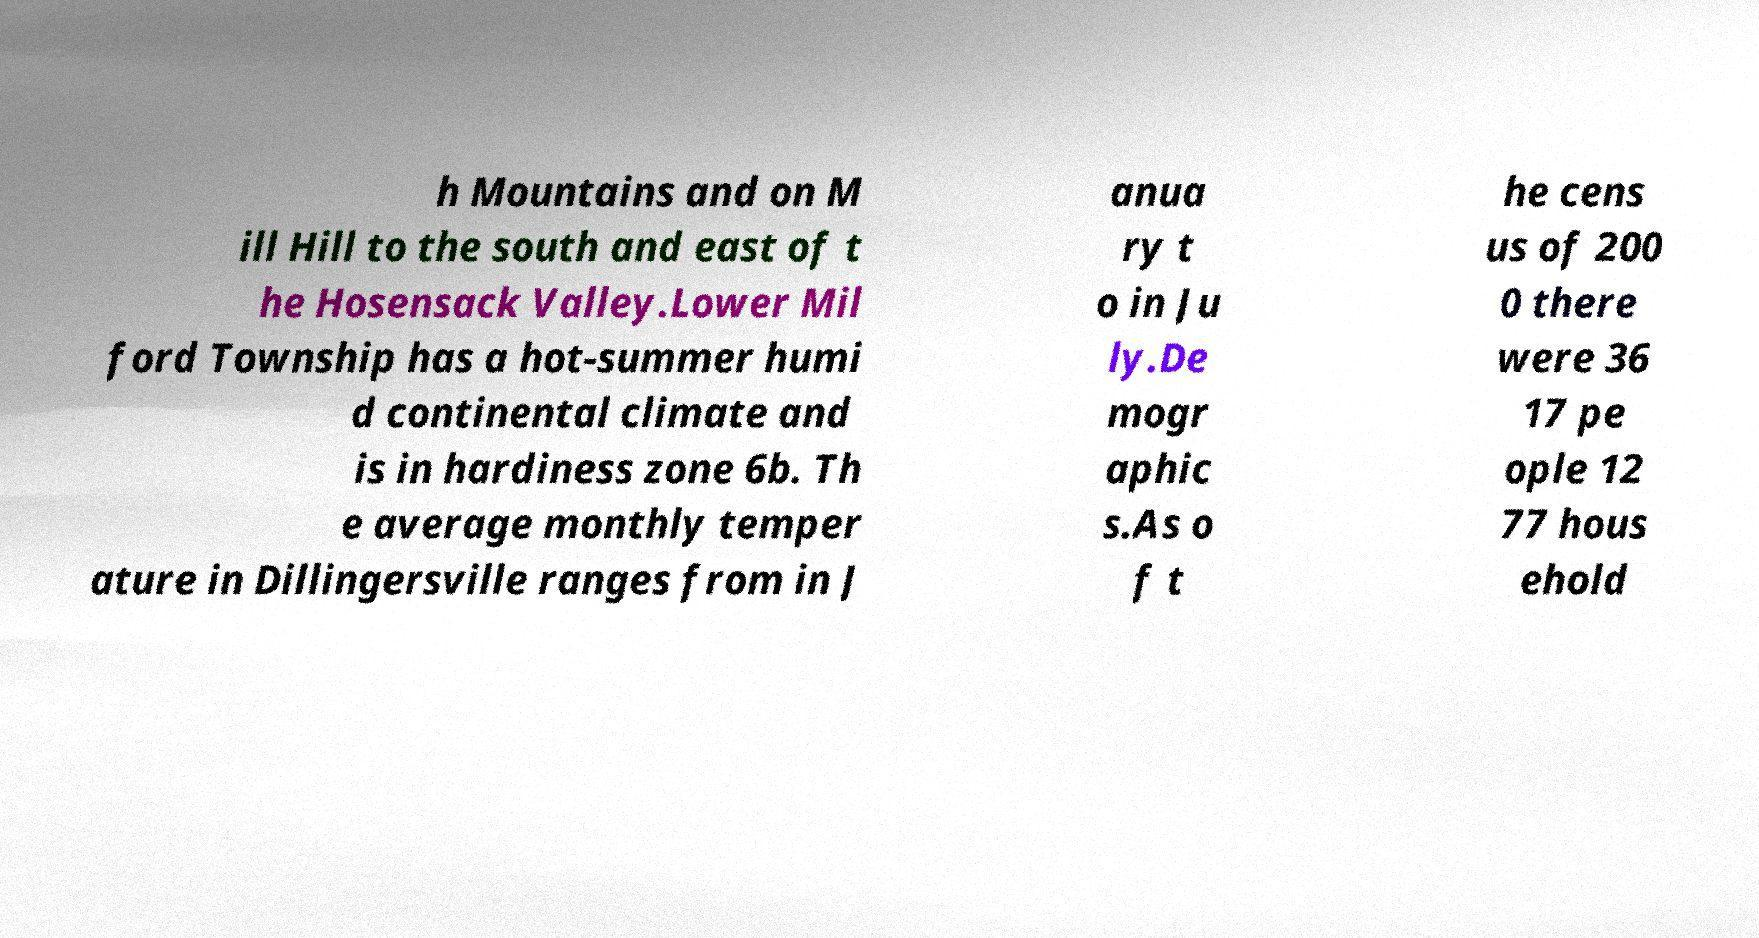Could you extract and type out the text from this image? h Mountains and on M ill Hill to the south and east of t he Hosensack Valley.Lower Mil ford Township has a hot-summer humi d continental climate and is in hardiness zone 6b. Th e average monthly temper ature in Dillingersville ranges from in J anua ry t o in Ju ly.De mogr aphic s.As o f t he cens us of 200 0 there were 36 17 pe ople 12 77 hous ehold 